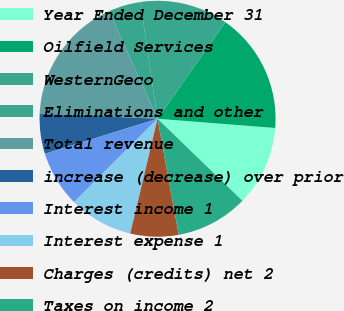Convert chart to OTSL. <chart><loc_0><loc_0><loc_500><loc_500><pie_chart><fcel>Year Ended December 31<fcel>Oilfield Services<fcel>WesternGeco<fcel>Eliminations and other<fcel>Total revenue<fcel>increase (decrease) over prior<fcel>Interest income 1<fcel>Interest expense 1<fcel>Charges (credits) net 2<fcel>Taxes on income 2<nl><fcel>10.99%<fcel>16.48%<fcel>12.09%<fcel>4.4%<fcel>17.58%<fcel>5.49%<fcel>7.69%<fcel>8.79%<fcel>6.59%<fcel>9.89%<nl></chart> 